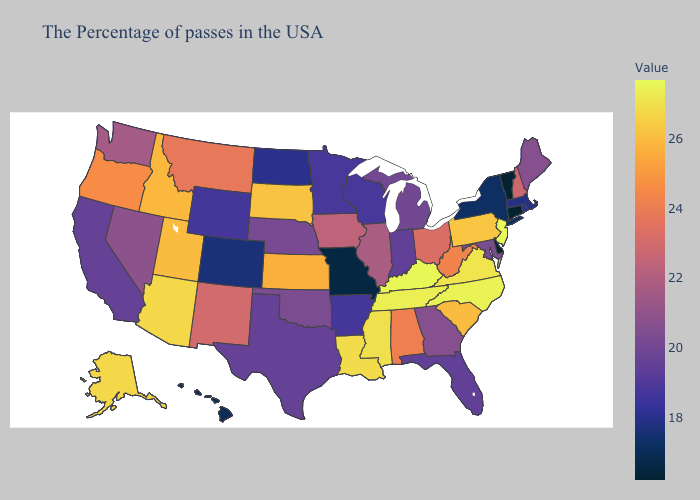Does Kentucky have the highest value in the USA?
Short answer required. No. Which states have the lowest value in the USA?
Concise answer only. Vermont, Connecticut, Delaware. Does the map have missing data?
Quick response, please. No. Does Ohio have the lowest value in the USA?
Keep it brief. No. Which states have the lowest value in the USA?
Write a very short answer. Vermont, Connecticut, Delaware. 